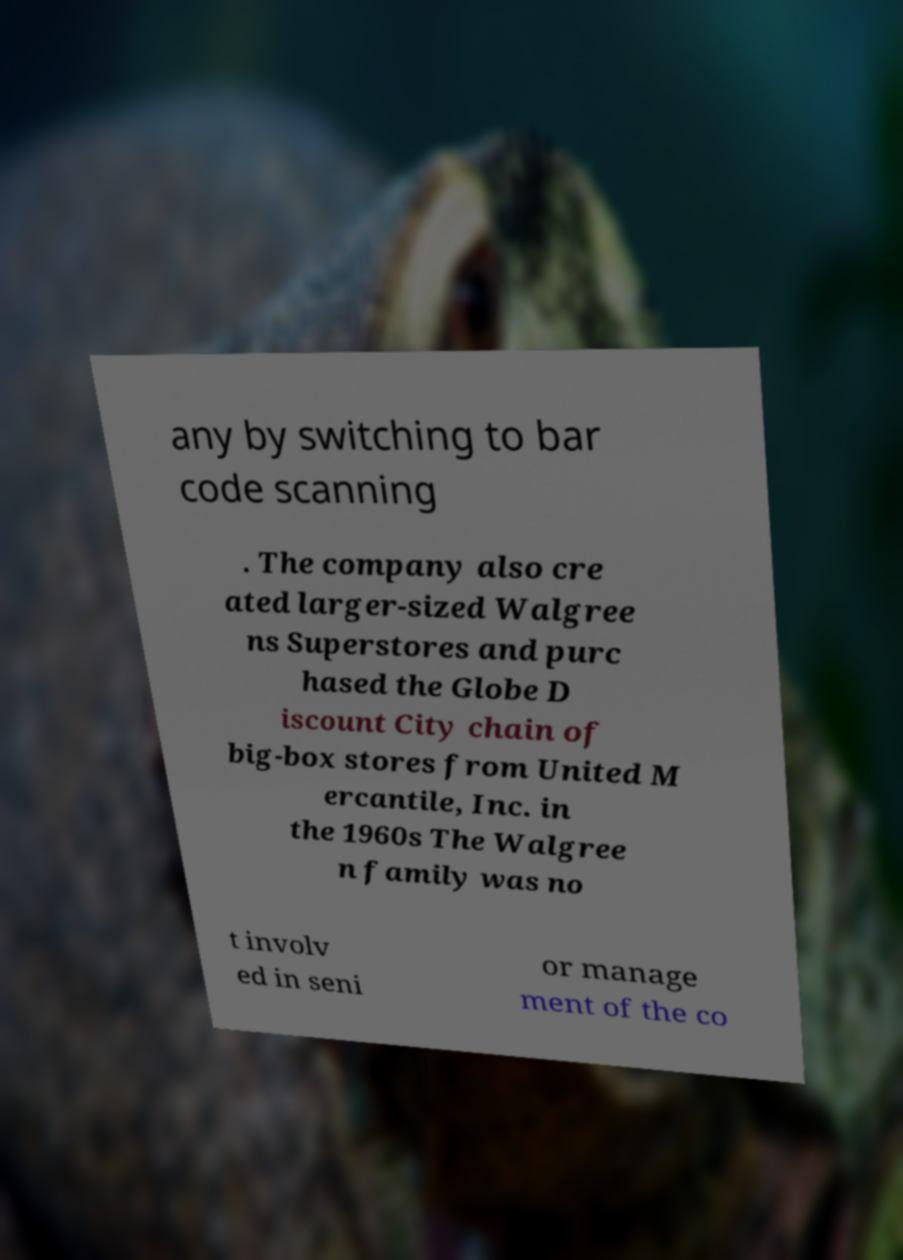Please read and relay the text visible in this image. What does it say? any by switching to bar code scanning . The company also cre ated larger-sized Walgree ns Superstores and purc hased the Globe D iscount City chain of big-box stores from United M ercantile, Inc. in the 1960s The Walgree n family was no t involv ed in seni or manage ment of the co 